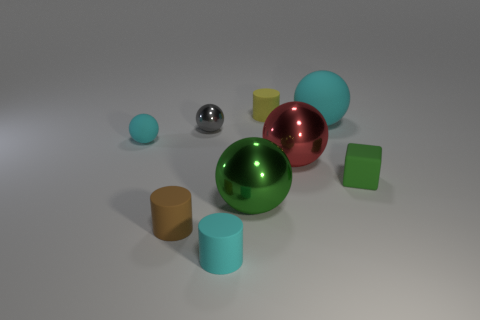Subtract all green spheres. How many spheres are left? 4 Subtract 2 balls. How many balls are left? 3 Subtract all small matte spheres. How many spheres are left? 4 Subtract all purple balls. Subtract all brown cylinders. How many balls are left? 5 Add 1 big brown rubber balls. How many objects exist? 10 Subtract all cylinders. How many objects are left? 6 Add 7 tiny cyan balls. How many tiny cyan balls are left? 8 Add 3 small cyan matte cylinders. How many small cyan matte cylinders exist? 4 Subtract 1 green spheres. How many objects are left? 8 Subtract all brown matte cylinders. Subtract all red spheres. How many objects are left? 7 